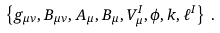<formula> <loc_0><loc_0><loc_500><loc_500>\left \{ g _ { \mu \nu } , B _ { \mu \nu } , A _ { \mu } , B _ { \mu } , V _ { \mu } ^ { I } , \phi , k , \ell ^ { I } \right \} \, .</formula> 